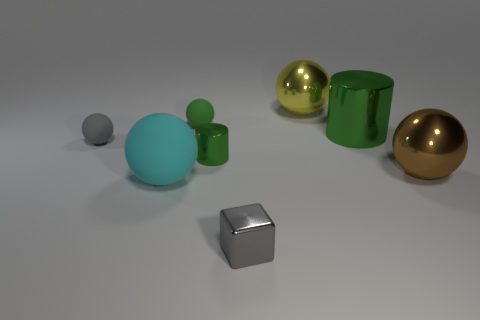How many brown metal things are the same size as the gray ball? 0 